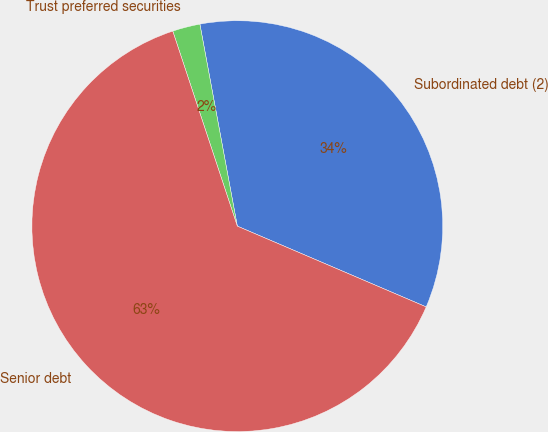Convert chart. <chart><loc_0><loc_0><loc_500><loc_500><pie_chart><fcel>Subordinated debt (2)<fcel>Trust preferred securities<fcel>Senior debt<nl><fcel>34.35%<fcel>2.17%<fcel>63.48%<nl></chart> 